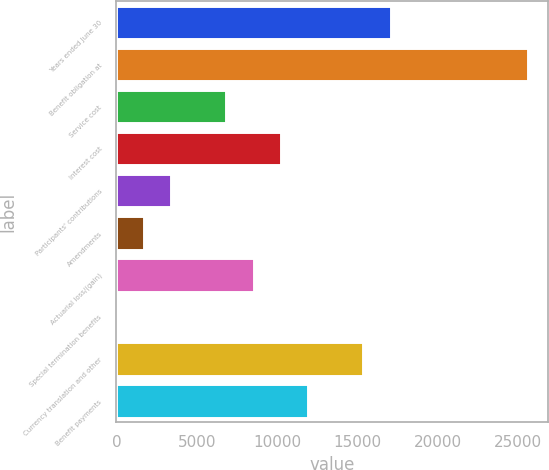Convert chart to OTSL. <chart><loc_0><loc_0><loc_500><loc_500><bar_chart><fcel>Years ended June 30<fcel>Benefit obligation at<fcel>Service cost<fcel>Interest cost<fcel>Participants' contributions<fcel>Amendments<fcel>Actuarial loss/(gain)<fcel>Special termination benefits<fcel>Currency translation and other<fcel>Benefit payments<nl><fcel>17053<fcel>25574<fcel>6827.8<fcel>10236.2<fcel>3419.4<fcel>1715.2<fcel>8532<fcel>11<fcel>15348.8<fcel>11940.4<nl></chart> 